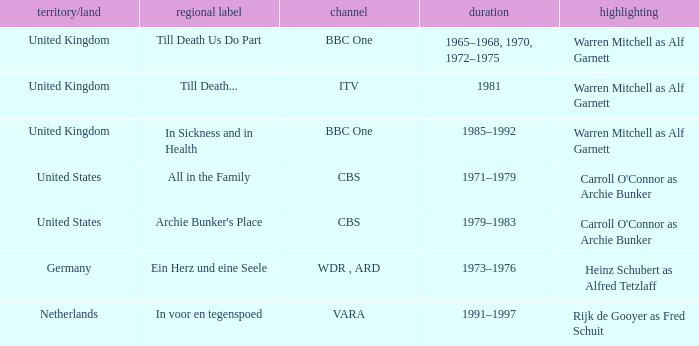What is the local name for the episodes that aired in 1981? Till Death... 